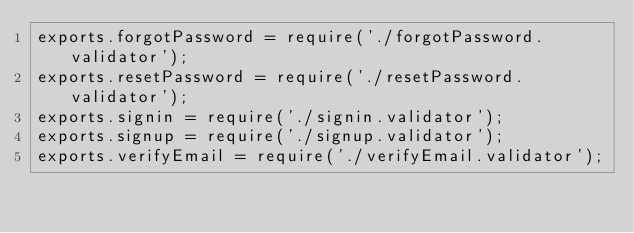Convert code to text. <code><loc_0><loc_0><loc_500><loc_500><_JavaScript_>exports.forgotPassword = require('./forgotPassword.validator');
exports.resetPassword = require('./resetPassword.validator');
exports.signin = require('./signin.validator');
exports.signup = require('./signup.validator');
exports.verifyEmail = require('./verifyEmail.validator');
</code> 